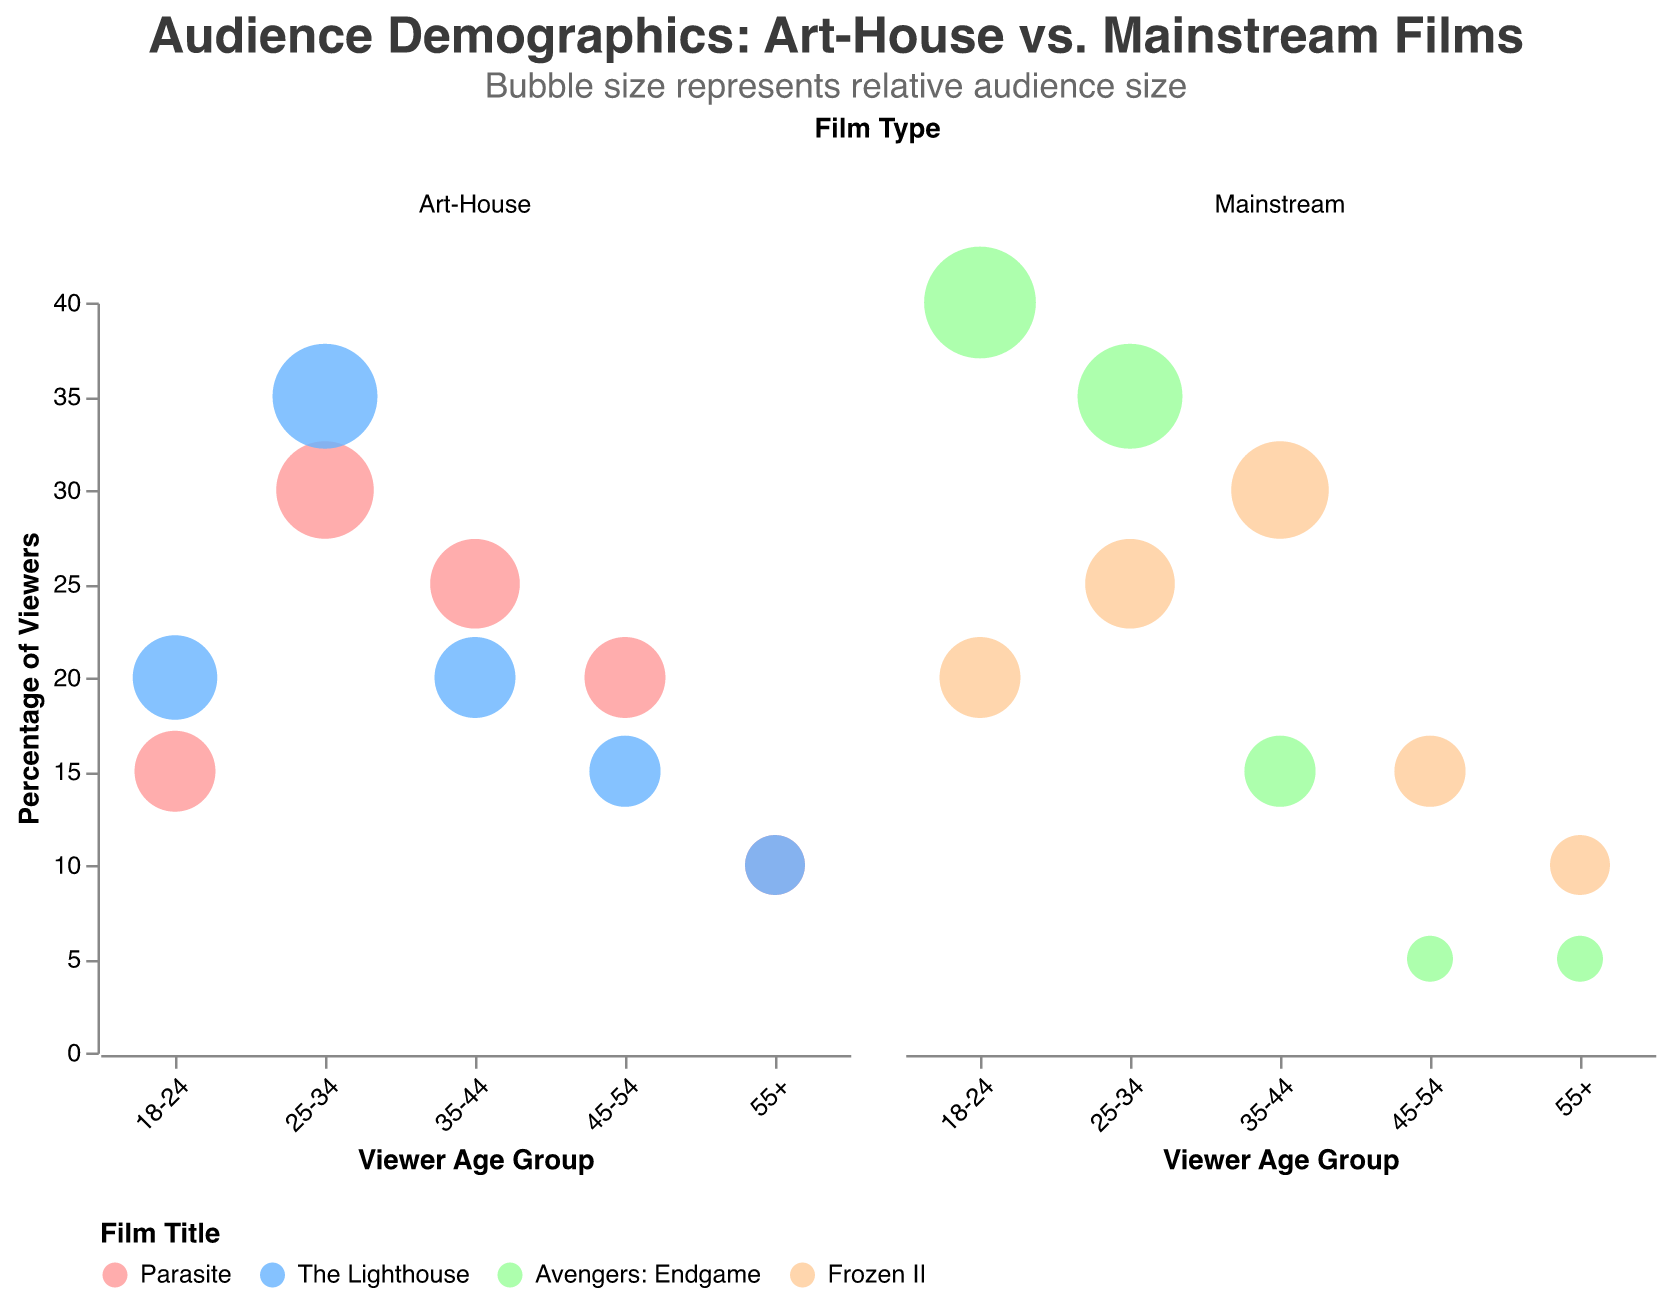What's the title of the figure? The title is prominently displayed at the top of the chart. It reads "Audience Demographics: Art-House vs. Mainstream Films", which tells us the overall theme of the chart.
Answer: Audience Demographics: Art-House vs. Mainstream Films Which film title is indicated by the color blue in the chart? The legend at the bottom of the chart aligns each film title with a specific color. The color blue corresponds to "The Lighthouse."
Answer: The Lighthouse Which age group has the highest percentage of viewers for "Avengers: Endgame"? By examining the bubbles for "Avengers: Endgame" in the Mainstream film column, the largest bubble in terms of percentage of viewers is for the "18-24" age group.
Answer: 18-24 Identify the age group that has the smallest bubble size for "Parasite". Within the Art-House section, observing the bubbles for "Parasite," the "55+" age group has the smallest bubble size.
Answer: 55+ How does the percentage of viewers in the 25-34 age group compare for "Parasite" and "Frozen II"? To make this comparison, look at the 25-34 age group bubbles in both the Art-House (for Parasite) and Mainstream (for Frozen II) columns. "Parasite" has a 30% viewers percentage while "Frozen II" has 25%.
Answer: Parasite has a higher percentage What is the average rating for the most-viewed age group of "The Lighthouse"? First, identify the age group with the largest bubble for "The Lighthouse" in the Art-House film type. The "25-34" age group has the largest bubble, and the average rating shown is 7.9.
Answer: 7.9 For "Frozen II", which age group has a percentage of viewers equal to 30%? By scanning the Mainstream film type for "Frozen II", the bubble corresponding to the 35-44 age group has a 30% viewer percentage.
Answer: 35-44 How does the viewer percentage for the 45-54 age group of "Parasite" compare to that of "Frozen II"? Look at the 45-54 age group bubbles for both, "Parasite" (Art-House) has a 20% viewer percentage and "Frozen II" (Mainstream) has 15%.
Answer: Parasite is higher Which film has the lowest average rating in the chart? Check the tooltips for all bubbles to compare average ratings. "Frozen II" has a rating of 7.5, which is the lowest among all listed films.
Answer: Frozen II How does the distribution of viewer percentages across age groups differ between "The Lighthouse" and "Avengers: Endgame"? Observing both bubble distributions: "The Lighthouse" shows a fairly even spread with the 25-34 age group being the highest. In contrast, "Avengers: Endgame" has a significantly higher percentage in the 18-24 age group, tapering off in older groups.
Answer: "The Lighthouse" is more evenly spread; "Avengers: Endgame" is concentrated in younger groups 